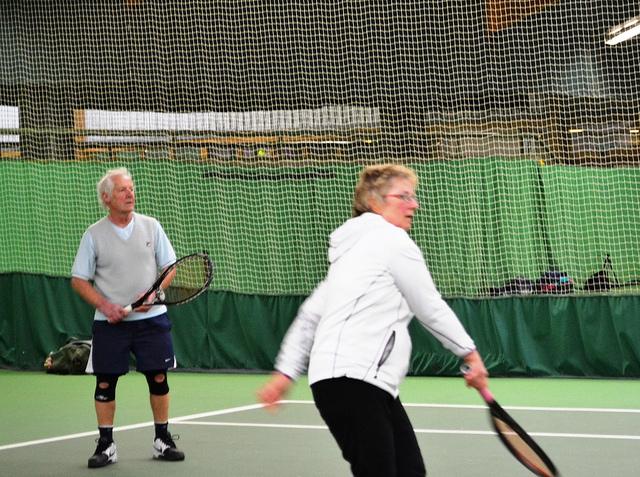What does the man have on his knees?
Be succinct. Braces. Are they playing doubles?
Answer briefly. Yes. What is the man wearing on his knees?
Quick response, please. Braces. 